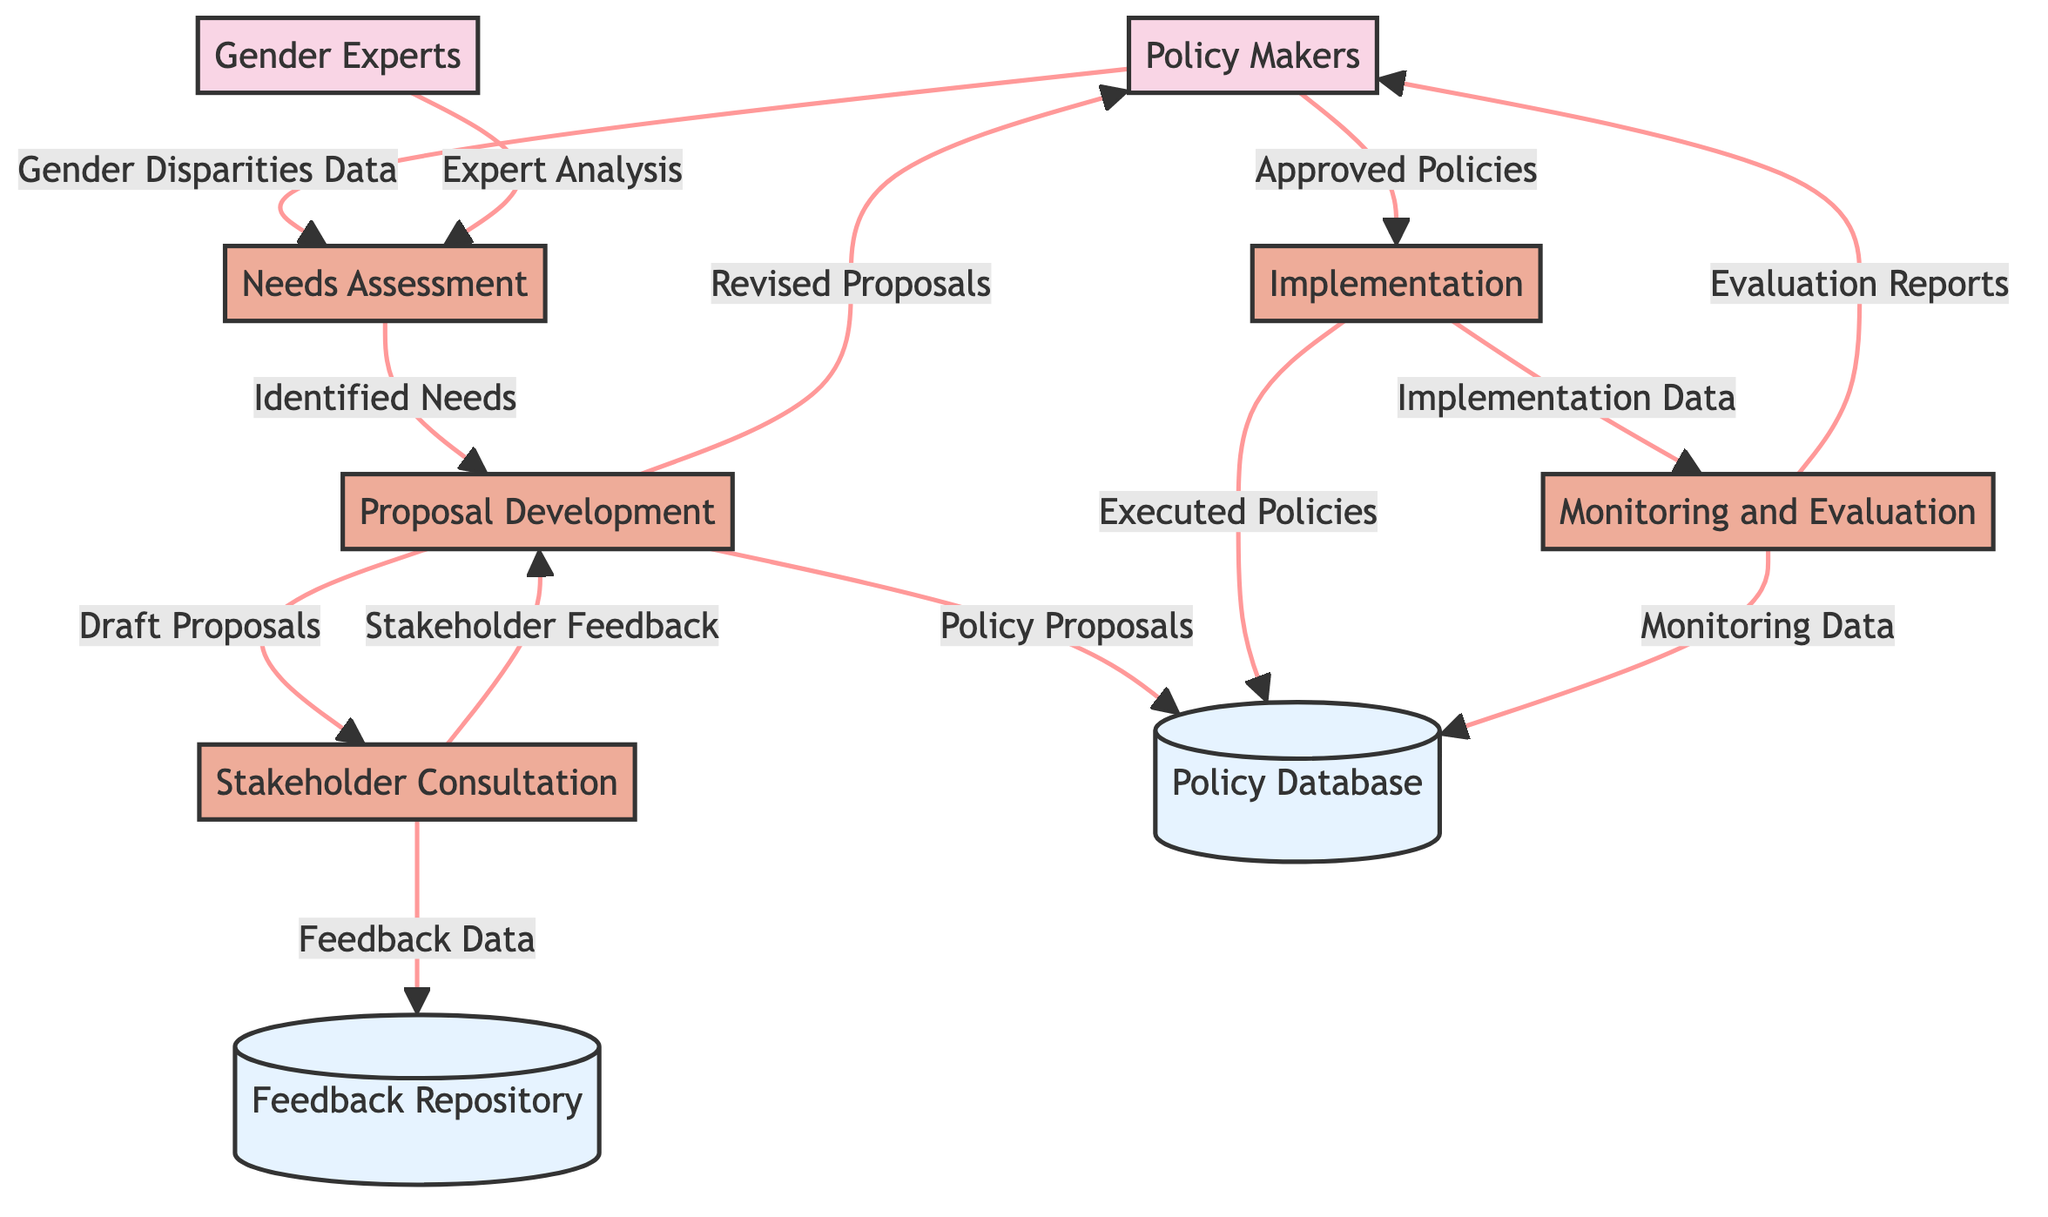What is the first process in the diagram? The first process is indicated by the flow coming from the external entities, which points to "Needs Assessment." This process is essential for laying the groundwork for the gender mainstreaming project.
Answer: Needs Assessment How many external entities are present in the diagram? The diagram shows two external entities: Policy Makers and Gender Experts. Both play important roles in the overall development cycle of the projects.
Answer: 2 What data flows from Policy Makers to Needs Assessment? The diagram indicates that "Gender Disparities Data" flows from Policy Makers to the Needs Assessment process, which is critical for identifying areas for improvement.
Answer: Gender Disparities Data What process follows Proposal Development? The flow from Proposal Development goes to Stakeholder Consultation, indicating that this is the next step after formulating proposals for gender mainstreaming strategies.
Answer: Stakeholder Consultation What data is stored in the Feedback Repository? The Feedback Repository contains "Feedback Data" coming from Stakeholder Consultation, which includes collected insights from affected communities and other stakeholders.
Answer: Feedback Data What is the final output that flows to Policy Makers from Monitoring and Evaluation? The last output from the Monitoring and Evaluation process is "Evaluation Reports," which assess the success and impact of the implemented policies before they are reported back to Policy Makers.
Answer: Evaluation Reports Which process involves engaging with affected communities? Stakeholder Consultation is the process dedicated to engaging with affected communities, NGOs, and other stakeholders for their input and feedback on gender mainstreaming strategies.
Answer: Stakeholder Consultation How many processes are represented in the diagram? There are five process nodes represented, which include Needs Assessment, Proposal Development, Stakeholder Consultation, Implementation, and Monitoring and Evaluation.
Answer: 5 What retrieves data from the Policy Database? The processes that retrieve or involve data from the Policy Database include Proposal Development, Implementation, and Monitoring and Evaluation, as they utilize and update the stored policies and data.
Answer: Proposal Development, Implementation, Monitoring and Evaluation 